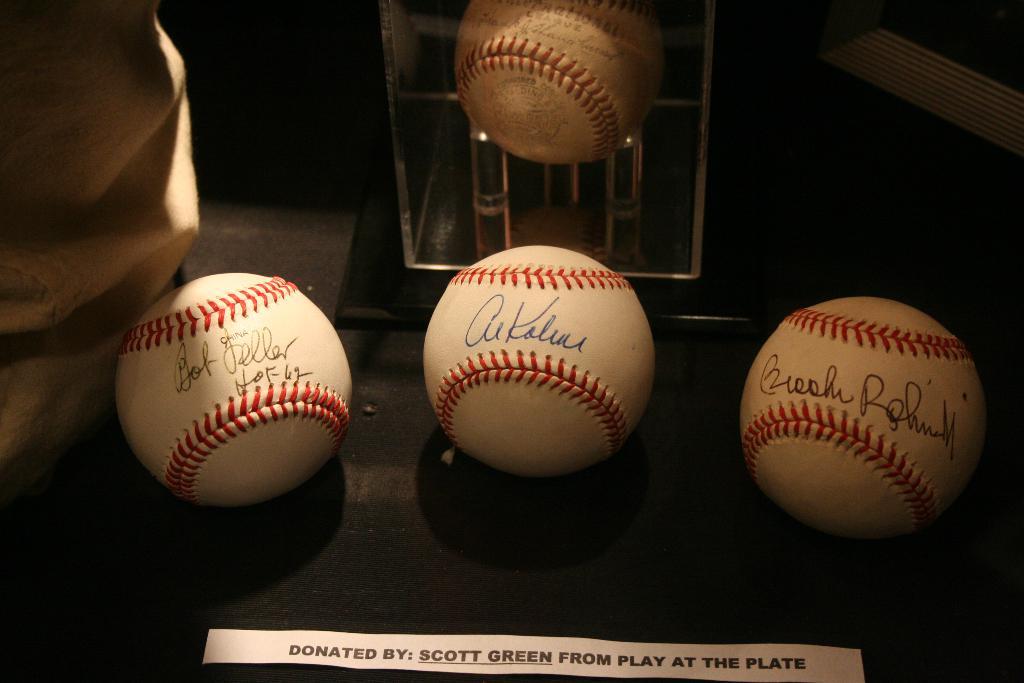Who donated these balls?
Offer a terse response. Scott green. What were these donated from according to the paper?
Offer a very short reply. Play at the plate. 